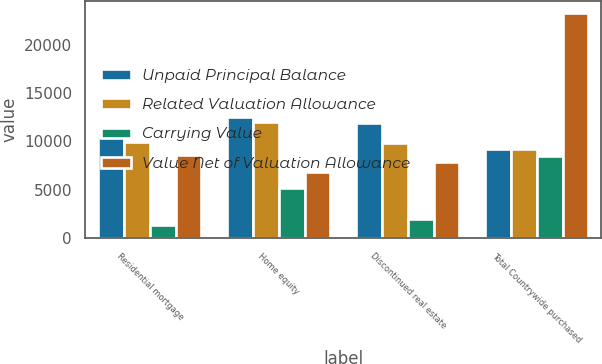<chart> <loc_0><loc_0><loc_500><loc_500><stacked_bar_chart><ecel><fcel>Residential mortgage<fcel>Home equity<fcel>Discontinued real estate<fcel>Total Countrywide purchased<nl><fcel>Unpaid Principal Balance<fcel>10426<fcel>12516<fcel>11891<fcel>9246<nl><fcel>Related Valuation Allowance<fcel>9966<fcel>11978<fcel>9857<fcel>9246<nl><fcel>Carrying Value<fcel>1331<fcel>5129<fcel>1999<fcel>8459<nl><fcel>Value Net of Valuation Allowance<fcel>8635<fcel>6849<fcel>7858<fcel>23342<nl></chart> 